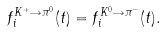Convert formula to latex. <formula><loc_0><loc_0><loc_500><loc_500>f ^ { K ^ { + } \rightarrow \pi ^ { 0 } } _ { i } ( t ) = f ^ { K ^ { 0 } \rightarrow \pi ^ { - } } _ { i } ( t ) .</formula> 